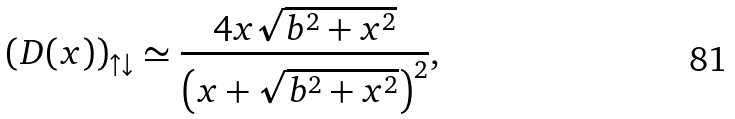Convert formula to latex. <formula><loc_0><loc_0><loc_500><loc_500>\left ( D ( x ) \right ) _ { \uparrow \downarrow } \simeq \frac { 4 x \sqrt { b ^ { 2 } + x ^ { 2 } } } { \left ( x + \sqrt { b ^ { 2 } + x ^ { 2 } } \right ) ^ { 2 } } ,</formula> 